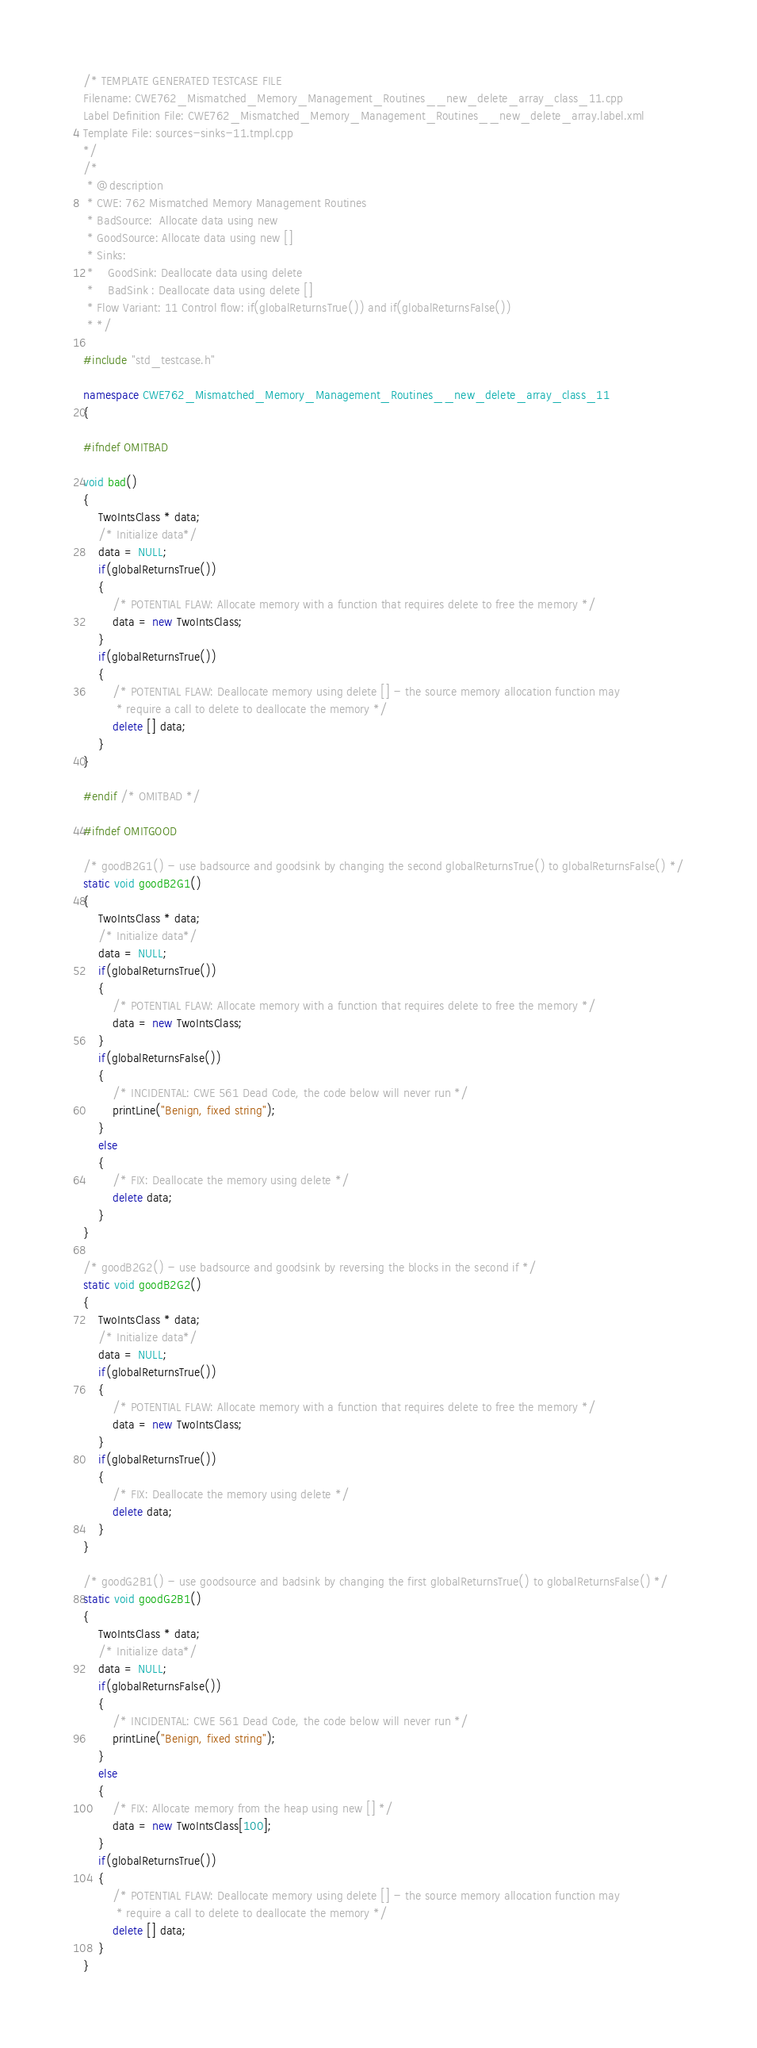Convert code to text. <code><loc_0><loc_0><loc_500><loc_500><_C++_>/* TEMPLATE GENERATED TESTCASE FILE
Filename: CWE762_Mismatched_Memory_Management_Routines__new_delete_array_class_11.cpp
Label Definition File: CWE762_Mismatched_Memory_Management_Routines__new_delete_array.label.xml
Template File: sources-sinks-11.tmpl.cpp
*/
/*
 * @description
 * CWE: 762 Mismatched Memory Management Routines
 * BadSource:  Allocate data using new
 * GoodSource: Allocate data using new []
 * Sinks:
 *    GoodSink: Deallocate data using delete
 *    BadSink : Deallocate data using delete []
 * Flow Variant: 11 Control flow: if(globalReturnsTrue()) and if(globalReturnsFalse())
 * */

#include "std_testcase.h"

namespace CWE762_Mismatched_Memory_Management_Routines__new_delete_array_class_11
{

#ifndef OMITBAD

void bad()
{
    TwoIntsClass * data;
    /* Initialize data*/
    data = NULL;
    if(globalReturnsTrue())
    {
        /* POTENTIAL FLAW: Allocate memory with a function that requires delete to free the memory */
        data = new TwoIntsClass;
    }
    if(globalReturnsTrue())
    {
        /* POTENTIAL FLAW: Deallocate memory using delete [] - the source memory allocation function may
         * require a call to delete to deallocate the memory */
        delete [] data;
    }
}

#endif /* OMITBAD */

#ifndef OMITGOOD

/* goodB2G1() - use badsource and goodsink by changing the second globalReturnsTrue() to globalReturnsFalse() */
static void goodB2G1()
{
    TwoIntsClass * data;
    /* Initialize data*/
    data = NULL;
    if(globalReturnsTrue())
    {
        /* POTENTIAL FLAW: Allocate memory with a function that requires delete to free the memory */
        data = new TwoIntsClass;
    }
    if(globalReturnsFalse())
    {
        /* INCIDENTAL: CWE 561 Dead Code, the code below will never run */
        printLine("Benign, fixed string");
    }
    else
    {
        /* FIX: Deallocate the memory using delete */
        delete data;
    }
}

/* goodB2G2() - use badsource and goodsink by reversing the blocks in the second if */
static void goodB2G2()
{
    TwoIntsClass * data;
    /* Initialize data*/
    data = NULL;
    if(globalReturnsTrue())
    {
        /* POTENTIAL FLAW: Allocate memory with a function that requires delete to free the memory */
        data = new TwoIntsClass;
    }
    if(globalReturnsTrue())
    {
        /* FIX: Deallocate the memory using delete */
        delete data;
    }
}

/* goodG2B1() - use goodsource and badsink by changing the first globalReturnsTrue() to globalReturnsFalse() */
static void goodG2B1()
{
    TwoIntsClass * data;
    /* Initialize data*/
    data = NULL;
    if(globalReturnsFalse())
    {
        /* INCIDENTAL: CWE 561 Dead Code, the code below will never run */
        printLine("Benign, fixed string");
    }
    else
    {
        /* FIX: Allocate memory from the heap using new [] */
        data = new TwoIntsClass[100];
    }
    if(globalReturnsTrue())
    {
        /* POTENTIAL FLAW: Deallocate memory using delete [] - the source memory allocation function may
         * require a call to delete to deallocate the memory */
        delete [] data;
    }
}
</code> 